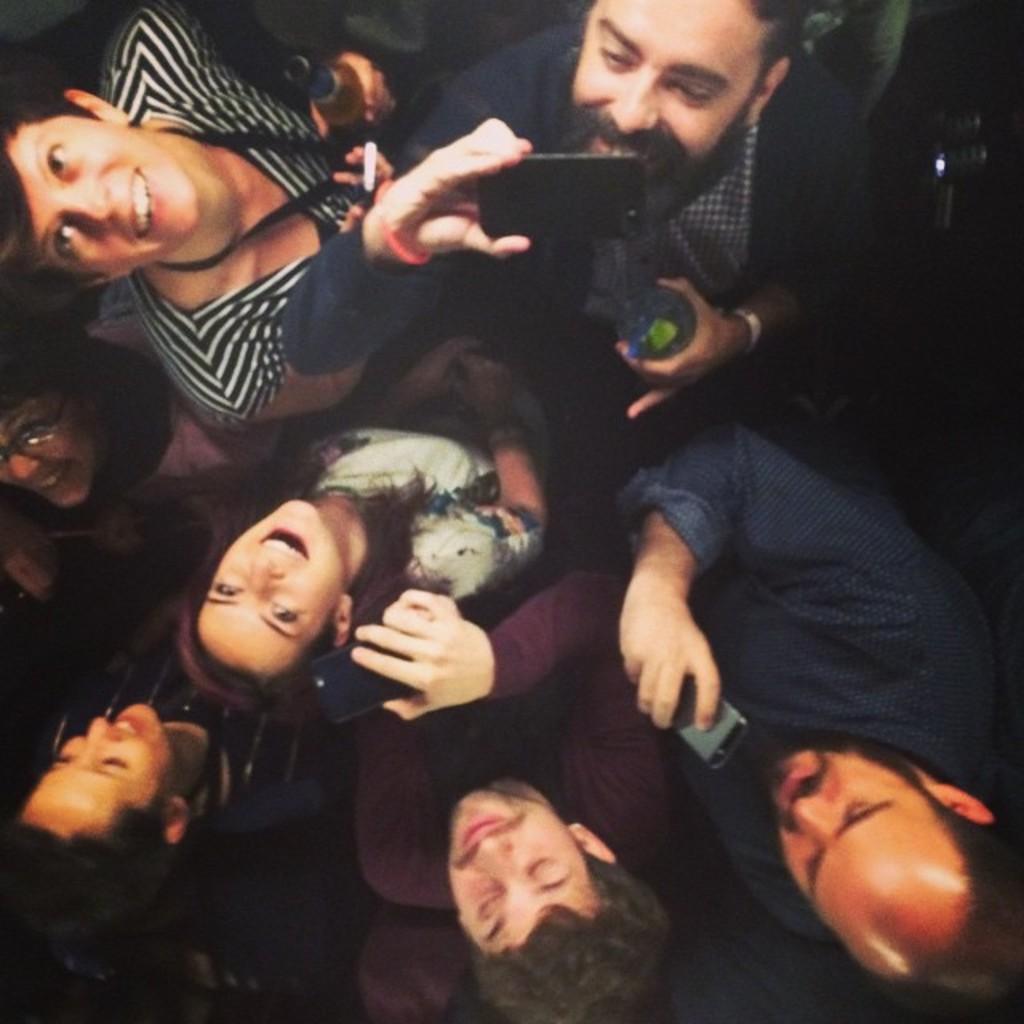Could you give a brief overview of what you see in this image? In this image we can see a group of people and few people are holding some objects in their hands. 